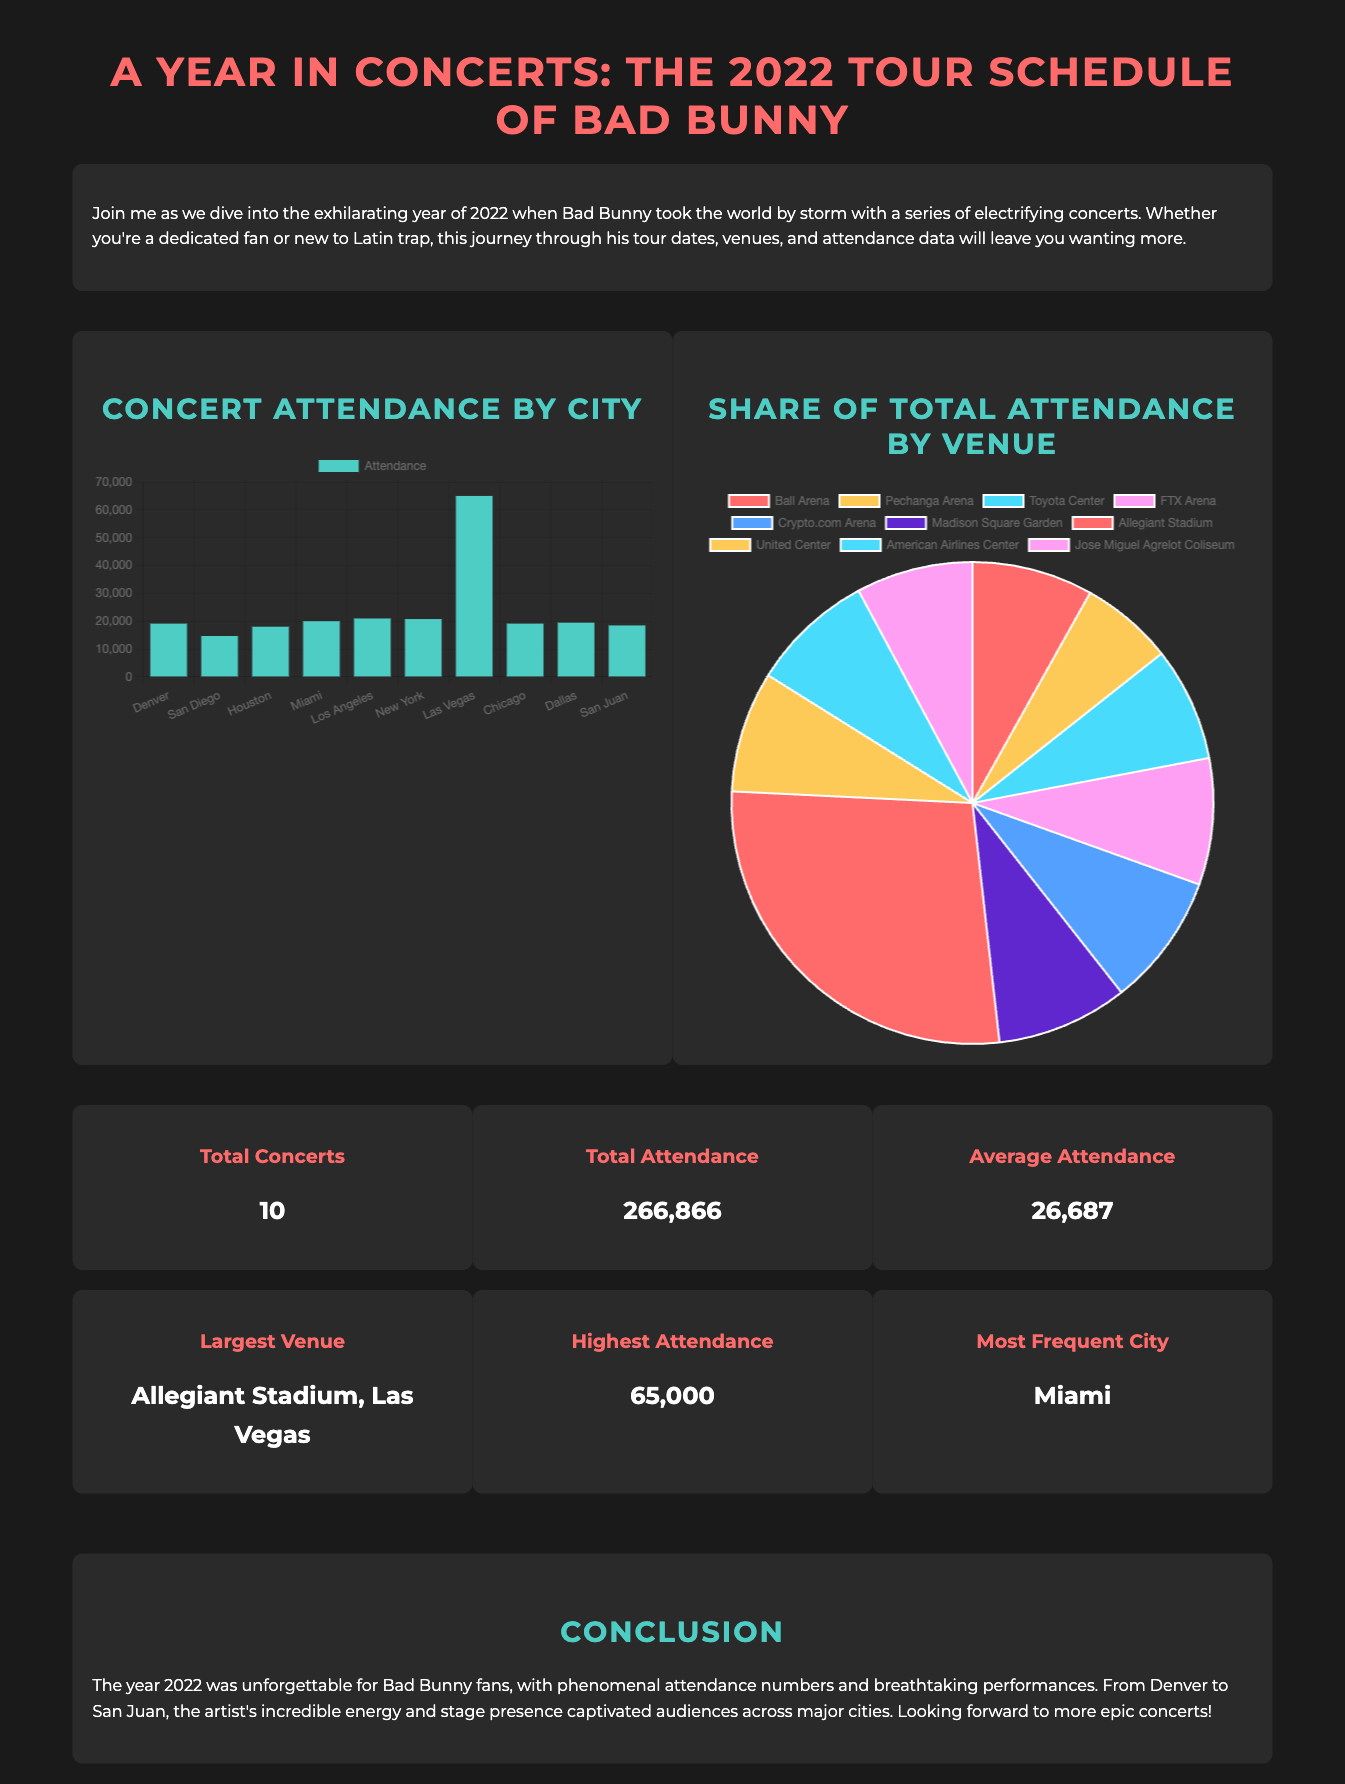What is the total number of concerts? The document states the total number of concerts performed by Bad Bunny in 2022 as 10.
Answer: 10 What is the total attendance figure? The total attendance is given in the summary section, indicating a count of 266,866 concertgoers.
Answer: 266,866 Which city had the highest attendance? The attendance chart indicates that Las Vegas had the highest number of attendees, with a count of 65,000.
Answer: Las Vegas What was the average attendance across the concerts? The average attendance is calculated and provided in the summary, which is 26,687.
Answer: 26,687 Which venue had the largest attendance share? The pie chart shows that Allegiant Stadium had the largest share of total attendance, represented as 24.36%.
Answer: Allegiant Stadium Which city is listed as the most frequent concert location? The summary section highlights Miami as the most frequently visited city for the concerts.
Answer: Miami How many attendees were present at the concert in Houston? The bar chart indicates that the attendance for the Houston concert was 18,043.
Answer: 18,043 Which venue was used for the concert in New York? The venue for the New York concert is identified in the pie chart, revealing it to be Madison Square Garden.
Answer: Madison Square Garden What date did the 2022 concert series conclude? The document does not specify dates, so the answer cannot be derived from the provided information.
Answer: Not specified 